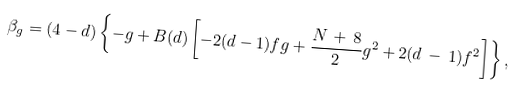<formula> <loc_0><loc_0><loc_500><loc_500>\beta _ { g } = ( 4 - d ) \left \{ - g + B ( d ) \left [ - 2 ( d - 1 ) f g + \frac { N \, + \, 8 } { 2 } g ^ { 2 } + 2 ( d \, - \, 1 ) f ^ { 2 } \right ] \right \} ,</formula> 